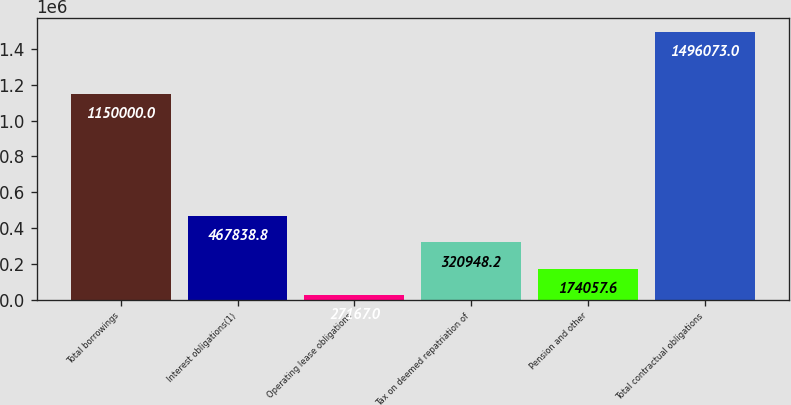<chart> <loc_0><loc_0><loc_500><loc_500><bar_chart><fcel>Total borrowings<fcel>Interest obligations(1)<fcel>Operating lease obligations<fcel>Tax on deemed repatriation of<fcel>Pension and other<fcel>Total contractual obligations<nl><fcel>1.15e+06<fcel>467839<fcel>27167<fcel>320948<fcel>174058<fcel>1.49607e+06<nl></chart> 